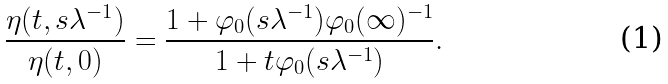Convert formula to latex. <formula><loc_0><loc_0><loc_500><loc_500>\frac { \eta ( t , s \lambda ^ { - 1 } ) } { \eta ( t , 0 ) } = \frac { 1 + \varphi _ { 0 } ( s \lambda ^ { - 1 } ) \varphi _ { 0 } ( \infty ) ^ { - 1 } } { 1 + t \varphi _ { 0 } ( s \lambda ^ { - 1 } ) } .</formula> 